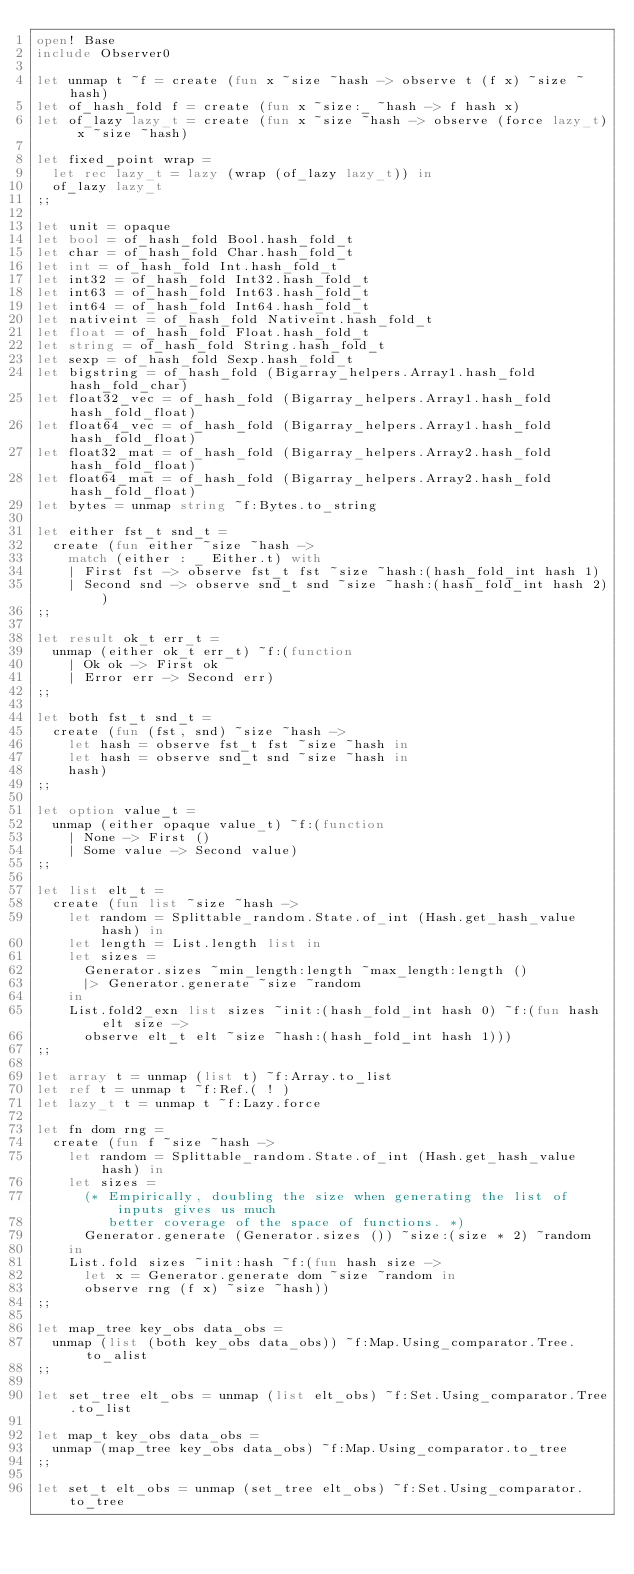Convert code to text. <code><loc_0><loc_0><loc_500><loc_500><_OCaml_>open! Base
include Observer0

let unmap t ~f = create (fun x ~size ~hash -> observe t (f x) ~size ~hash)
let of_hash_fold f = create (fun x ~size:_ ~hash -> f hash x)
let of_lazy lazy_t = create (fun x ~size ~hash -> observe (force lazy_t) x ~size ~hash)

let fixed_point wrap =
  let rec lazy_t = lazy (wrap (of_lazy lazy_t)) in
  of_lazy lazy_t
;;

let unit = opaque
let bool = of_hash_fold Bool.hash_fold_t
let char = of_hash_fold Char.hash_fold_t
let int = of_hash_fold Int.hash_fold_t
let int32 = of_hash_fold Int32.hash_fold_t
let int63 = of_hash_fold Int63.hash_fold_t
let int64 = of_hash_fold Int64.hash_fold_t
let nativeint = of_hash_fold Nativeint.hash_fold_t
let float = of_hash_fold Float.hash_fold_t
let string = of_hash_fold String.hash_fold_t
let sexp = of_hash_fold Sexp.hash_fold_t
let bigstring = of_hash_fold (Bigarray_helpers.Array1.hash_fold hash_fold_char)
let float32_vec = of_hash_fold (Bigarray_helpers.Array1.hash_fold hash_fold_float)
let float64_vec = of_hash_fold (Bigarray_helpers.Array1.hash_fold hash_fold_float)
let float32_mat = of_hash_fold (Bigarray_helpers.Array2.hash_fold hash_fold_float)
let float64_mat = of_hash_fold (Bigarray_helpers.Array2.hash_fold hash_fold_float)
let bytes = unmap string ~f:Bytes.to_string

let either fst_t snd_t =
  create (fun either ~size ~hash ->
    match (either : _ Either.t) with
    | First fst -> observe fst_t fst ~size ~hash:(hash_fold_int hash 1)
    | Second snd -> observe snd_t snd ~size ~hash:(hash_fold_int hash 2))
;;

let result ok_t err_t =
  unmap (either ok_t err_t) ~f:(function
    | Ok ok -> First ok
    | Error err -> Second err)
;;

let both fst_t snd_t =
  create (fun (fst, snd) ~size ~hash ->
    let hash = observe fst_t fst ~size ~hash in
    let hash = observe snd_t snd ~size ~hash in
    hash)
;;

let option value_t =
  unmap (either opaque value_t) ~f:(function
    | None -> First ()
    | Some value -> Second value)
;;

let list elt_t =
  create (fun list ~size ~hash ->
    let random = Splittable_random.State.of_int (Hash.get_hash_value hash) in
    let length = List.length list in
    let sizes =
      Generator.sizes ~min_length:length ~max_length:length ()
      |> Generator.generate ~size ~random
    in
    List.fold2_exn list sizes ~init:(hash_fold_int hash 0) ~f:(fun hash elt size ->
      observe elt_t elt ~size ~hash:(hash_fold_int hash 1)))
;;

let array t = unmap (list t) ~f:Array.to_list
let ref t = unmap t ~f:Ref.( ! )
let lazy_t t = unmap t ~f:Lazy.force

let fn dom rng =
  create (fun f ~size ~hash ->
    let random = Splittable_random.State.of_int (Hash.get_hash_value hash) in
    let sizes =
      (* Empirically, doubling the size when generating the list of inputs gives us much
         better coverage of the space of functions. *)
      Generator.generate (Generator.sizes ()) ~size:(size * 2) ~random
    in
    List.fold sizes ~init:hash ~f:(fun hash size ->
      let x = Generator.generate dom ~size ~random in
      observe rng (f x) ~size ~hash))
;;

let map_tree key_obs data_obs =
  unmap (list (both key_obs data_obs)) ~f:Map.Using_comparator.Tree.to_alist
;;

let set_tree elt_obs = unmap (list elt_obs) ~f:Set.Using_comparator.Tree.to_list

let map_t key_obs data_obs =
  unmap (map_tree key_obs data_obs) ~f:Map.Using_comparator.to_tree
;;

let set_t elt_obs = unmap (set_tree elt_obs) ~f:Set.Using_comparator.to_tree
</code> 